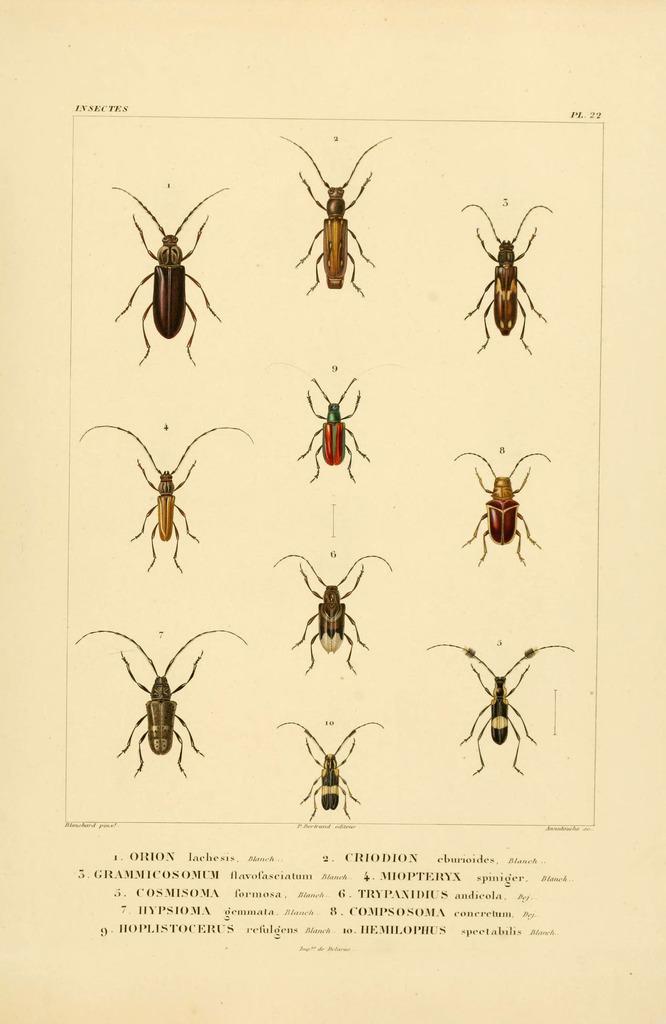Describe this image in one or two sentences. In this image I can see a poster in which I can see few insects which are red, green, black, brown and cream in color. I can see few words written in the bottom of the poster. 